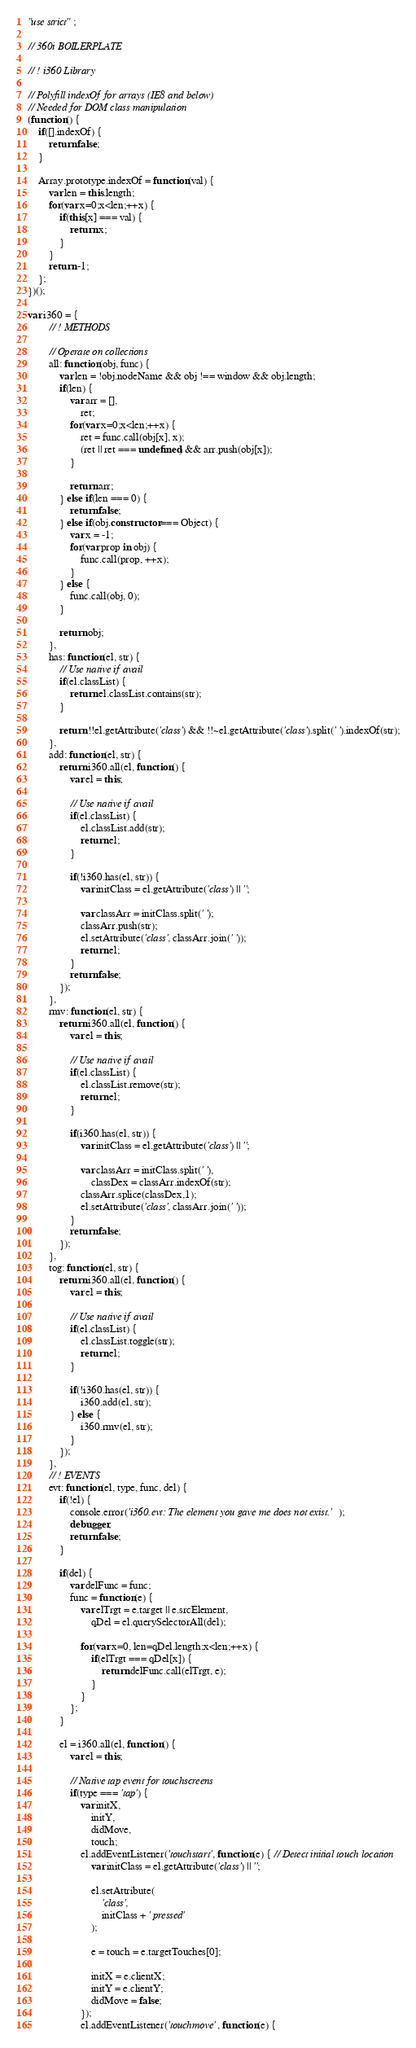Convert code to text. <code><loc_0><loc_0><loc_500><loc_500><_JavaScript_>"use strict";

// 360i BOILERPLATE

// ! i360 Library

// Polyfill indexOf for arrays (IE8 and below)
// Needed for DOM class manipulation
(function() {
	if([].indexOf) {
		return false;
	}

	Array.prototype.indexOf = function(val) {
		var len = this.length;
		for(var x=0;x<len;++x) {
			if(this[x] === val) {
				return x;
			}
		}
		return -1;
	};
})();

var i360 = {
		// ! METHODS

		// Operate on collections
		all: function(obj, func) {
			var len = !obj.nodeName && obj !== window && obj.length;
			if(len) {
				var arr = [],
					ret;
				for(var x=0;x<len;++x) {
					ret = func.call(obj[x], x);
					(ret || ret === undefined) && arr.push(obj[x]);
				}

				return arr;
			} else if(len === 0) {
				return false;
			} else if(obj.constructor === Object) {
				var x = -1;
				for(var prop in obj) {
					func.call(prop, ++x);
				}
			} else {
				func.call(obj, 0);
			}

			return obj;
		},
		has: function(el, str) {
			// Use native if avail
			if(el.classList) {
				return el.classList.contains(str);
			}

			return !!el.getAttribute('class') && !!~el.getAttribute('class').split(' ').indexOf(str);
		},
		add: function(el, str) {
			return i360.all(el, function() {
				var el = this;

				// Use native if avail
				if(el.classList) {
					el.classList.add(str);
					return el;
				}

				if(!i360.has(el, str)) {
					var initClass = el.getAttribute('class') || '';

					var classArr = initClass.split(' ');
					classArr.push(str);
					el.setAttribute('class', classArr.join(' '));
					return el;
				}
				return false;
			});
		},
		rmv: function(el, str) {
			return i360.all(el, function() {
				var el = this;

				// Use native if avail
				if(el.classList) {
					el.classList.remove(str);
					return el;
				}

				if(i360.has(el, str)) {
					var initClass = el.getAttribute('class') || '';

					var classArr = initClass.split(' '),
						classDex = classArr.indexOf(str);
					classArr.splice(classDex,1);
					el.setAttribute('class', classArr.join(' '));
				}
				return false;
			});
		},
		tog: function(el, str) {
			return i360.all(el, function() {
				var el = this;

				// Use native if avail
				if(el.classList) {
					el.classList.toggle(str);
					return el;
				}

				if(!i360.has(el, str)) {
					i360.add(el, str);
				} else {
					i360.rmv(el, str);
				}
			});
		},
		// ! EVENTS
		evt: function(el, type, func, del) {
			if(!el) {
				console.error('i360.evt: The element you gave me does not exist.');
				debugger;
				return false;
			}

			if(del) {
				var delFunc = func;
				func = function(e) {
					var elTrgt = e.target || e.srcElement,
						qDel = el.querySelectorAll(del);

					for(var x=0, len=qDel.length;x<len;++x) {
						if(elTrgt === qDel[x]) {
							return delFunc.call(elTrgt, e);
						}
					}
				};
			}

			el = i360.all(el, function() {
				var el = this;

				// Native tap event for touchscreens
				if(type === 'tap') {
					var initX,
						initY,
						didMove,
						touch;
					el.addEventListener('touchstart', function(e) { // Detect initial touch location
						var initClass = el.getAttribute('class') || '';

						el.setAttribute(
							'class',
							initClass + ' pressed'
						);

						e = touch = e.targetTouches[0];

						initX = e.clientX;
						initY = e.clientY;
						didMove = false;
					});
					el.addEventListener('touchmove', function(e) {</code> 